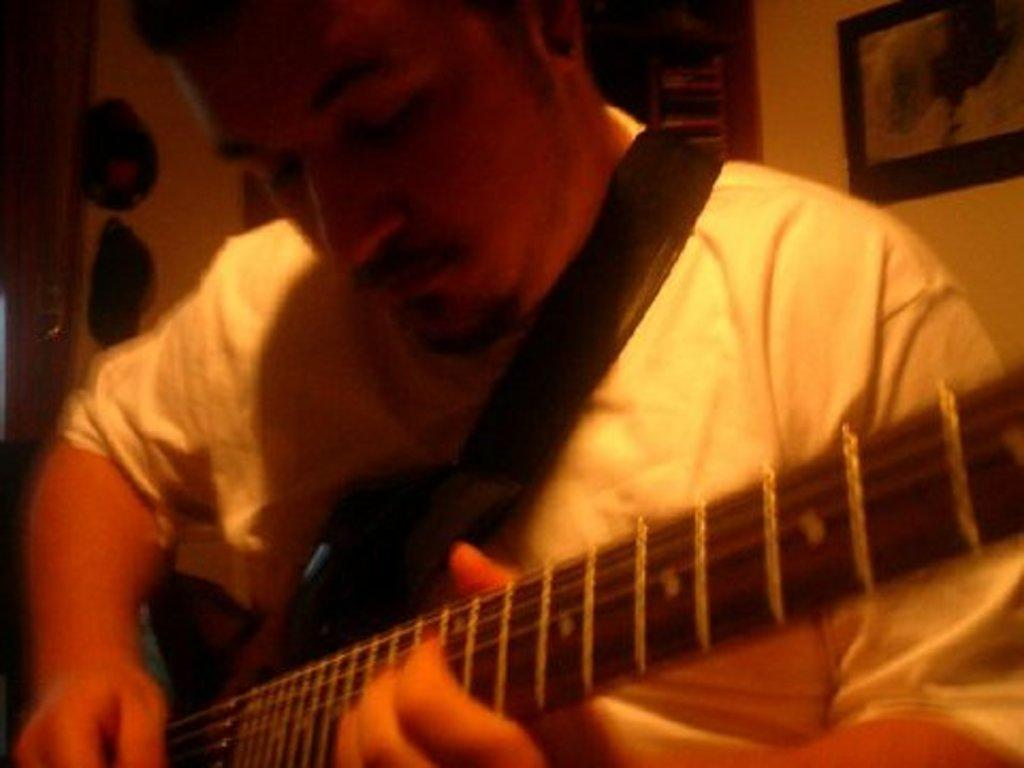Where was the image taken? The image was taken indoors. What can be seen in the background of the image? There is a wall with a picture frame in the background. Who is the main subject in the image? There is a man in the middle of the image. What is the man holding in his hands? The man is holding a guitar in his hands. What type of spade is the man using to play the guitar in the image? There is no spade present in the image, and the man is not using any tool to play the guitar. 